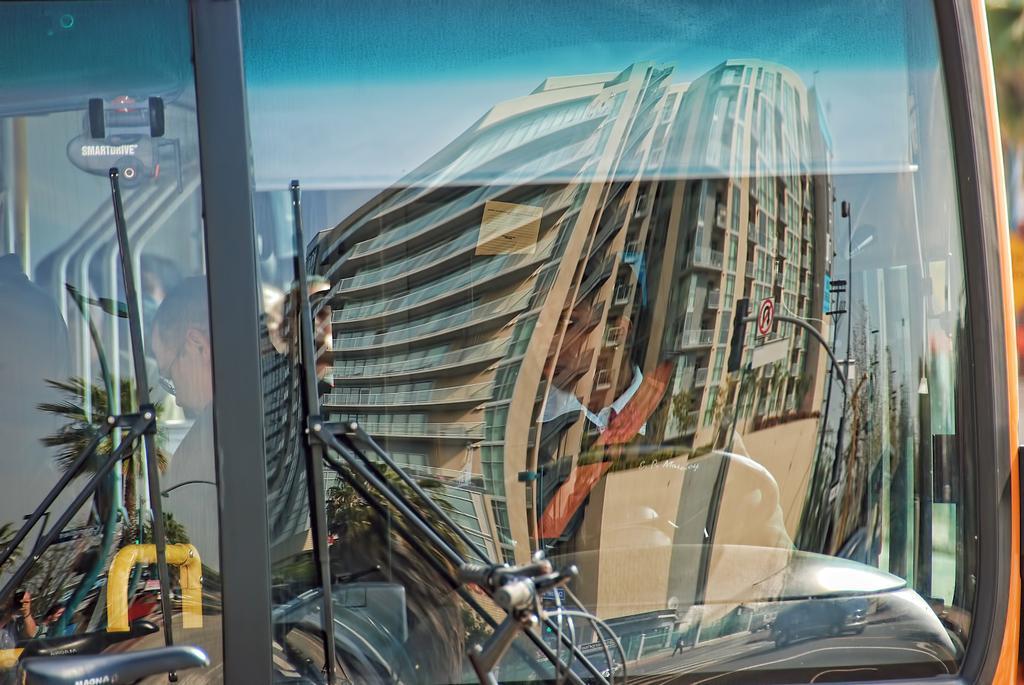How would you summarize this image in a sentence or two? It looks like a glass of a vehicle, there is a woman in this and there is an image in this image. It looks like a building. 